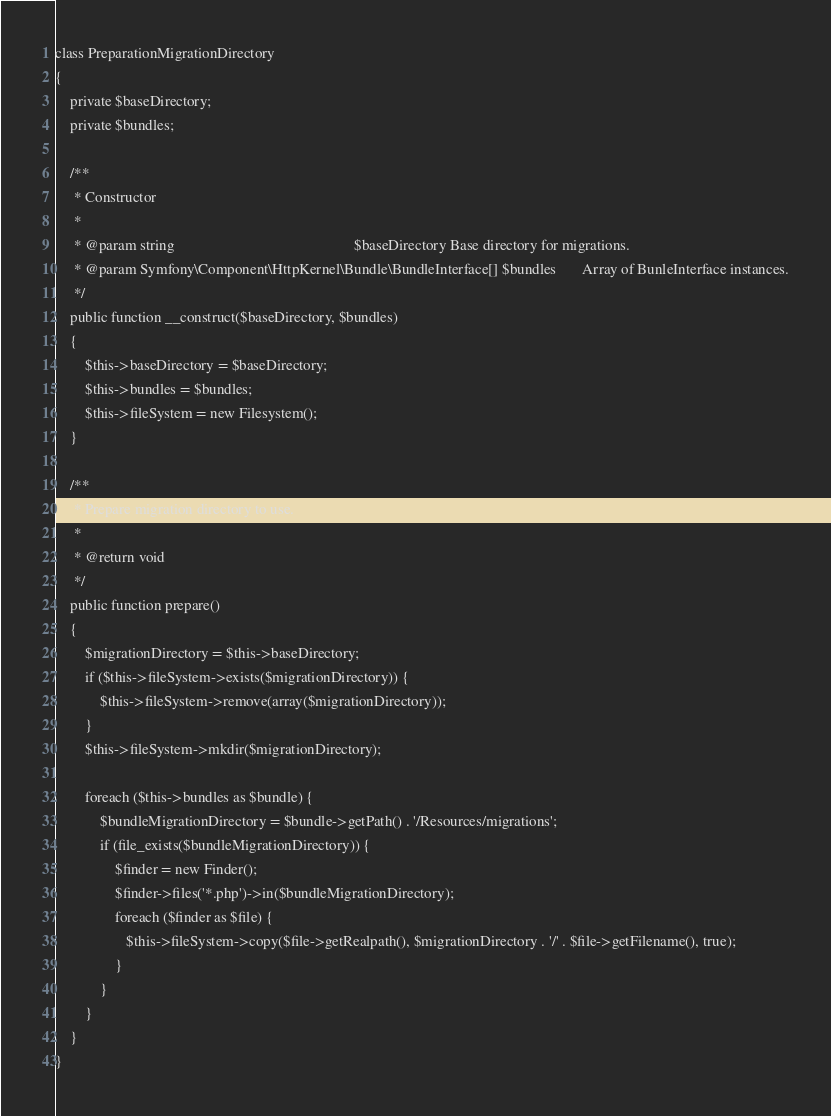Convert code to text. <code><loc_0><loc_0><loc_500><loc_500><_PHP_>
class PreparationMigrationDirectory
{
    private $baseDirectory;
    private $bundles;

    /**
     * Constructor
     *
     * @param string                                                $baseDirectory Base directory for migrations.
     * @param Symfony\Component\HttpKernel\Bundle\BundleInterface[] $bundles       Array of BunleInterface instances.
     */
    public function __construct($baseDirectory, $bundles)
    {
        $this->baseDirectory = $baseDirectory;
        $this->bundles = $bundles;
        $this->fileSystem = new Filesystem();
    }

    /**
     * Prepare migration directory to use.
     *
     * @return void
     */
    public function prepare()
    {
        $migrationDirectory = $this->baseDirectory;
        if ($this->fileSystem->exists($migrationDirectory)) {
            $this->fileSystem->remove(array($migrationDirectory));
        }
        $this->fileSystem->mkdir($migrationDirectory);

        foreach ($this->bundles as $bundle) {
            $bundleMigrationDirectory = $bundle->getPath() . '/Resources/migrations';
            if (file_exists($bundleMigrationDirectory)) {
                $finder = new Finder();
                $finder->files('*.php')->in($bundleMigrationDirectory);
                foreach ($finder as $file) {
                   $this->fileSystem->copy($file->getRealpath(), $migrationDirectory . '/' . $file->getFilename(), true);
                }
            }
        }
    }
}
</code> 